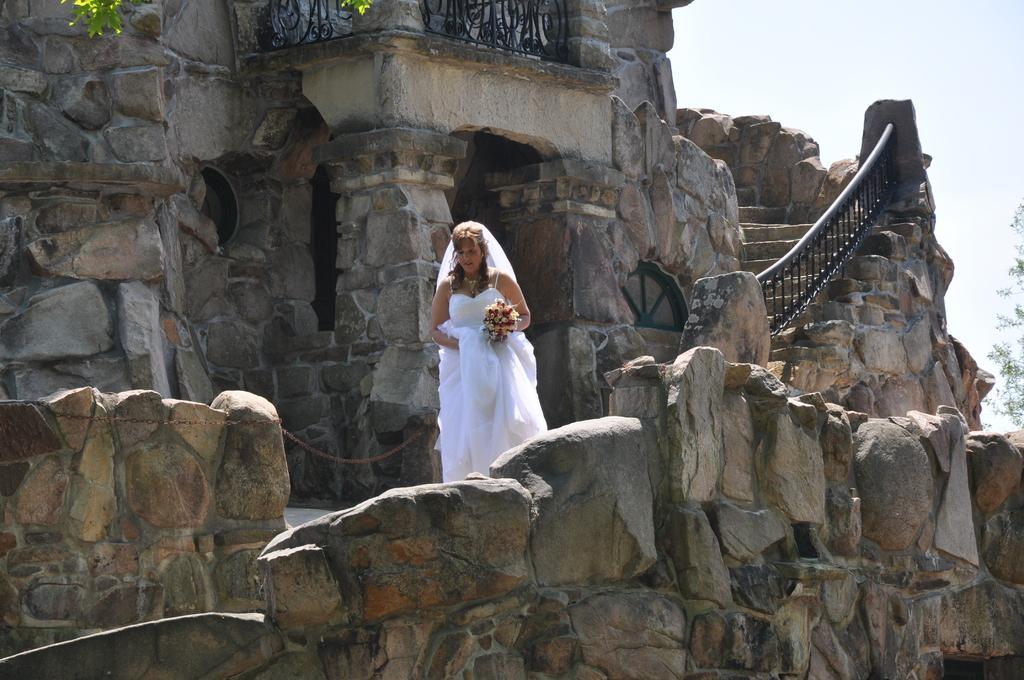In one or two sentences, can you explain what this image depicts? In this picture we can see a woman holding flower bouquet in the building. There is a tree on left side. 